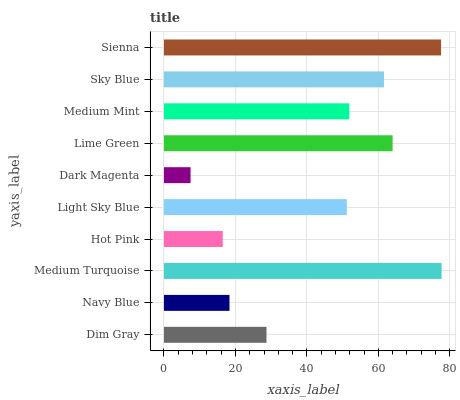Is Dark Magenta the minimum?
Answer yes or no. Yes. Is Medium Turquoise the maximum?
Answer yes or no. Yes. Is Navy Blue the minimum?
Answer yes or no. No. Is Navy Blue the maximum?
Answer yes or no. No. Is Dim Gray greater than Navy Blue?
Answer yes or no. Yes. Is Navy Blue less than Dim Gray?
Answer yes or no. Yes. Is Navy Blue greater than Dim Gray?
Answer yes or no. No. Is Dim Gray less than Navy Blue?
Answer yes or no. No. Is Medium Mint the high median?
Answer yes or no. Yes. Is Light Sky Blue the low median?
Answer yes or no. Yes. Is Hot Pink the high median?
Answer yes or no. No. Is Sky Blue the low median?
Answer yes or no. No. 